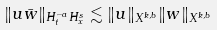Convert formula to latex. <formula><loc_0><loc_0><loc_500><loc_500>\| u \bar { w } \| _ { H ^ { - a } _ { t } H ^ { s } _ { x } } \lesssim \| u \| _ { X ^ { k , b } } \| w \| _ { X ^ { k , b } }</formula> 